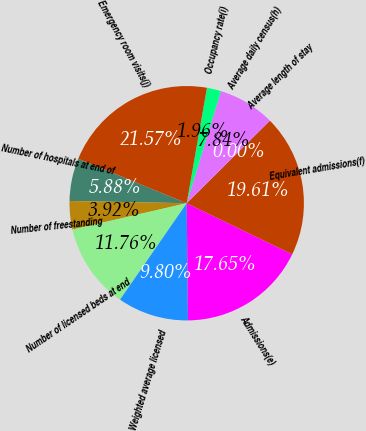<chart> <loc_0><loc_0><loc_500><loc_500><pie_chart><fcel>Number of hospitals at end of<fcel>Number of freestanding<fcel>Number of licensed beds at end<fcel>Weighted average licensed<fcel>Admissions(e)<fcel>Equivalent admissions(f)<fcel>Average length of stay<fcel>Average daily census(h)<fcel>Occupancy rate(i)<fcel>Emergency room visits(j)<nl><fcel>5.88%<fcel>3.92%<fcel>11.76%<fcel>9.8%<fcel>17.65%<fcel>19.61%<fcel>0.0%<fcel>7.84%<fcel>1.96%<fcel>21.57%<nl></chart> 